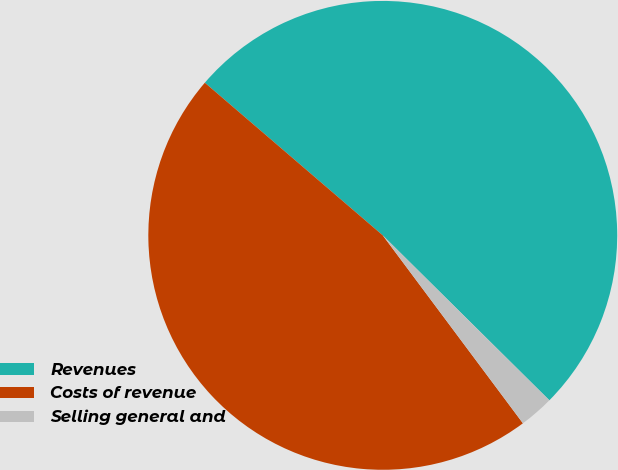Convert chart to OTSL. <chart><loc_0><loc_0><loc_500><loc_500><pie_chart><fcel>Revenues<fcel>Costs of revenue<fcel>Selling general and<nl><fcel>51.13%<fcel>46.48%<fcel>2.38%<nl></chart> 